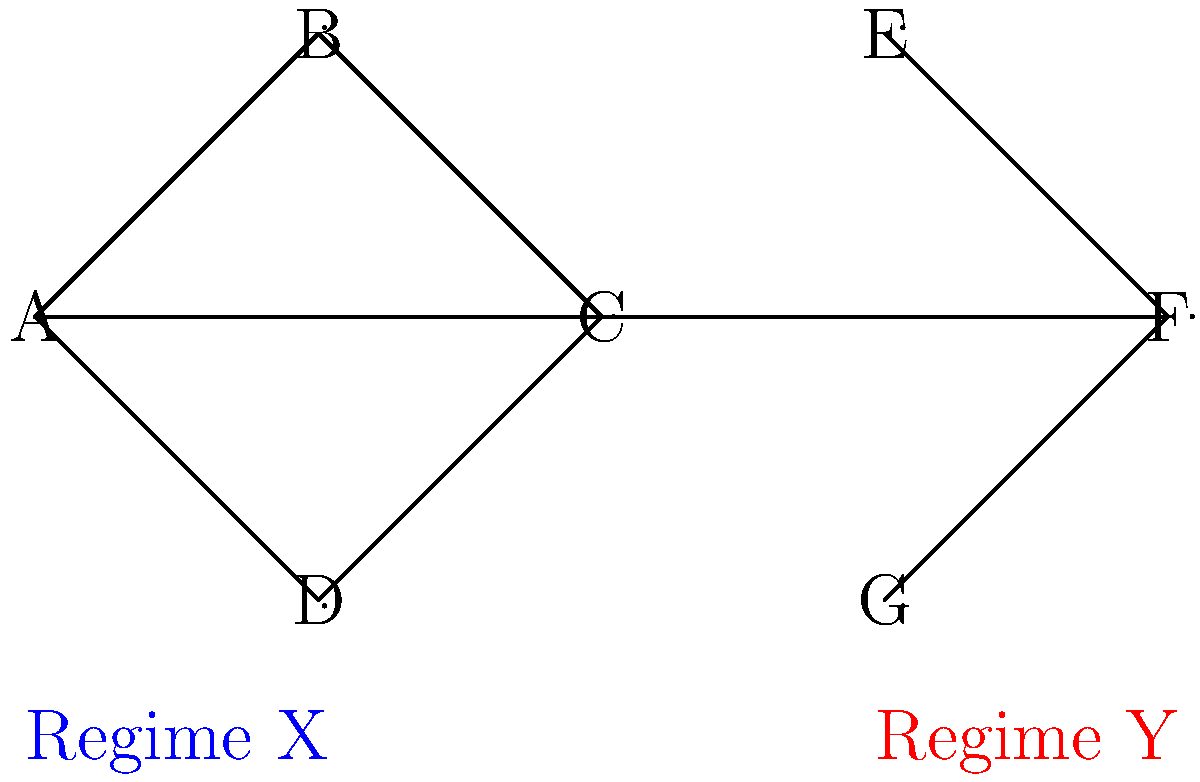In the graph above, startups are represented as nodes, and collaborations between them are represented as edges. The graph shows startup collaborations under two different regulatory regimes (X and Y). Calculate the average clustering coefficient for the entire network and explain how it reflects the impact of regulatory frameworks on startup collaborations. To solve this problem, we'll follow these steps:

1) First, let's calculate the clustering coefficient for each node:

   For a node $v$, the clustering coefficient $C_v$ is given by:
   $C_v = \frac{2 * e_v}{k_v * (k_v - 1)}$

   Where $e_v$ is the number of edges between the neighbors of $v$, and $k_v$ is the degree of $v$.

2) Regime X:
   Node A: $C_A = \frac{2 * 1}{3 * 2} = \frac{1}{3}$
   Node B: $C_B = \frac{2 * 1}{2 * 1} = 1$
   Node C: $C_C = \frac{2 * 1}{3 * 2} = \frac{1}{3}$
   Node D: $C_D = 0$ (only 1 neighbor)

3) Regime Y:
   Node E: $C_E = 0$ (only 1 neighbor)
   Node F: $C_F = 0$ (2 neighbors, but no edge between them)
   Node G: $C_G = 0$ (only 1 neighbor)

4) The average clustering coefficient is the mean of all individual coefficients:

   $C_{avg} = \frac{C_A + C_B + C_C + C_D + C_E + C_F + C_G}{7}$
   
   $C_{avg} = \frac{\frac{1}{3} + 1 + \frac{1}{3} + 0 + 0 + 0 + 0}{7} = \frac{5/3}{7} \approx 0.238$

5) Interpretation:
   The higher clustering coefficient in Regime X (left side) suggests that this regulatory framework promotes more tightly-knit collaborations among startups. In contrast, Regime Y (right side) shows a more dispersed collaboration pattern with lower clustering, indicating that this regulatory environment might encourage more diverse but less interconnected partnerships.
Answer: $C_{avg} \approx 0.238$; Regime X promotes tighter collaborations, while Regime Y encourages more diverse but less interconnected partnerships. 